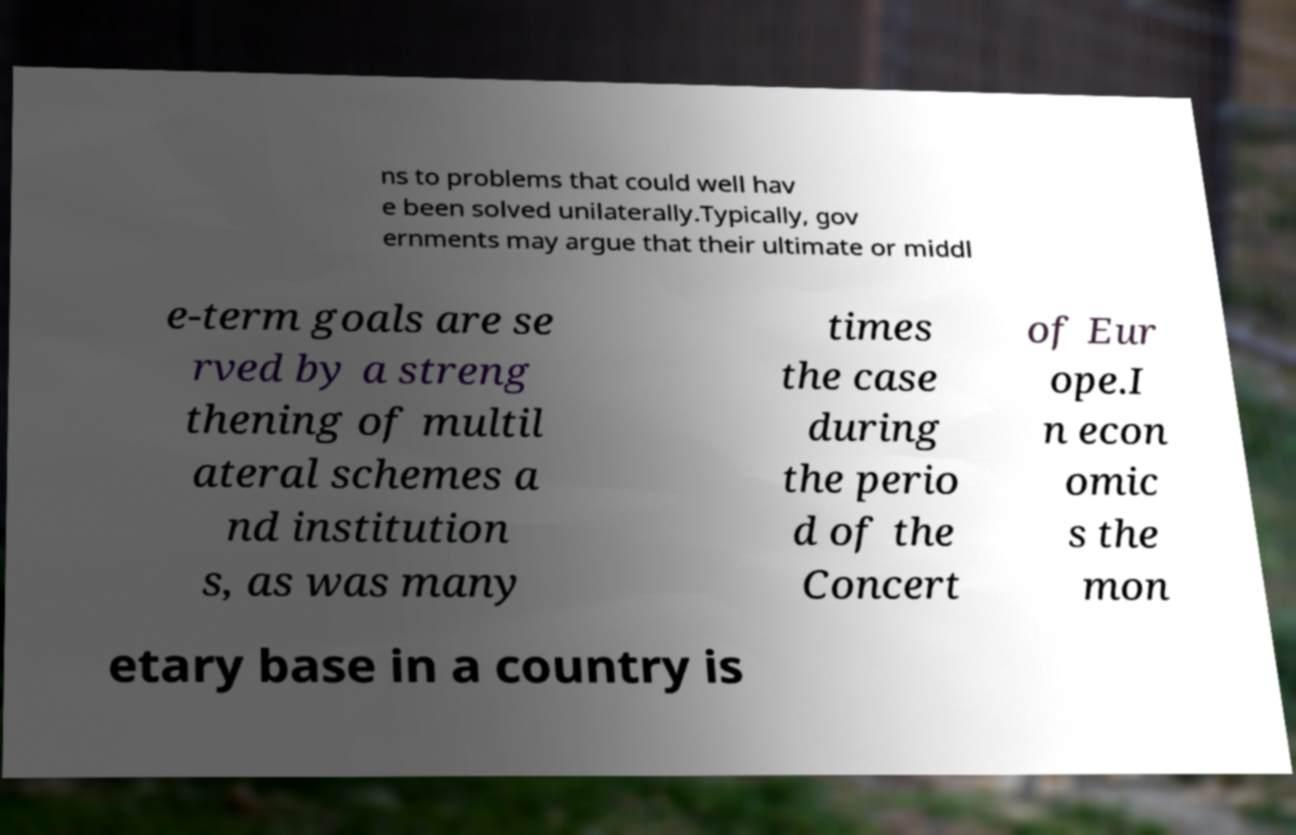Please read and relay the text visible in this image. What does it say? ns to problems that could well hav e been solved unilaterally.Typically, gov ernments may argue that their ultimate or middl e-term goals are se rved by a streng thening of multil ateral schemes a nd institution s, as was many times the case during the perio d of the Concert of Eur ope.I n econ omic s the mon etary base in a country is 